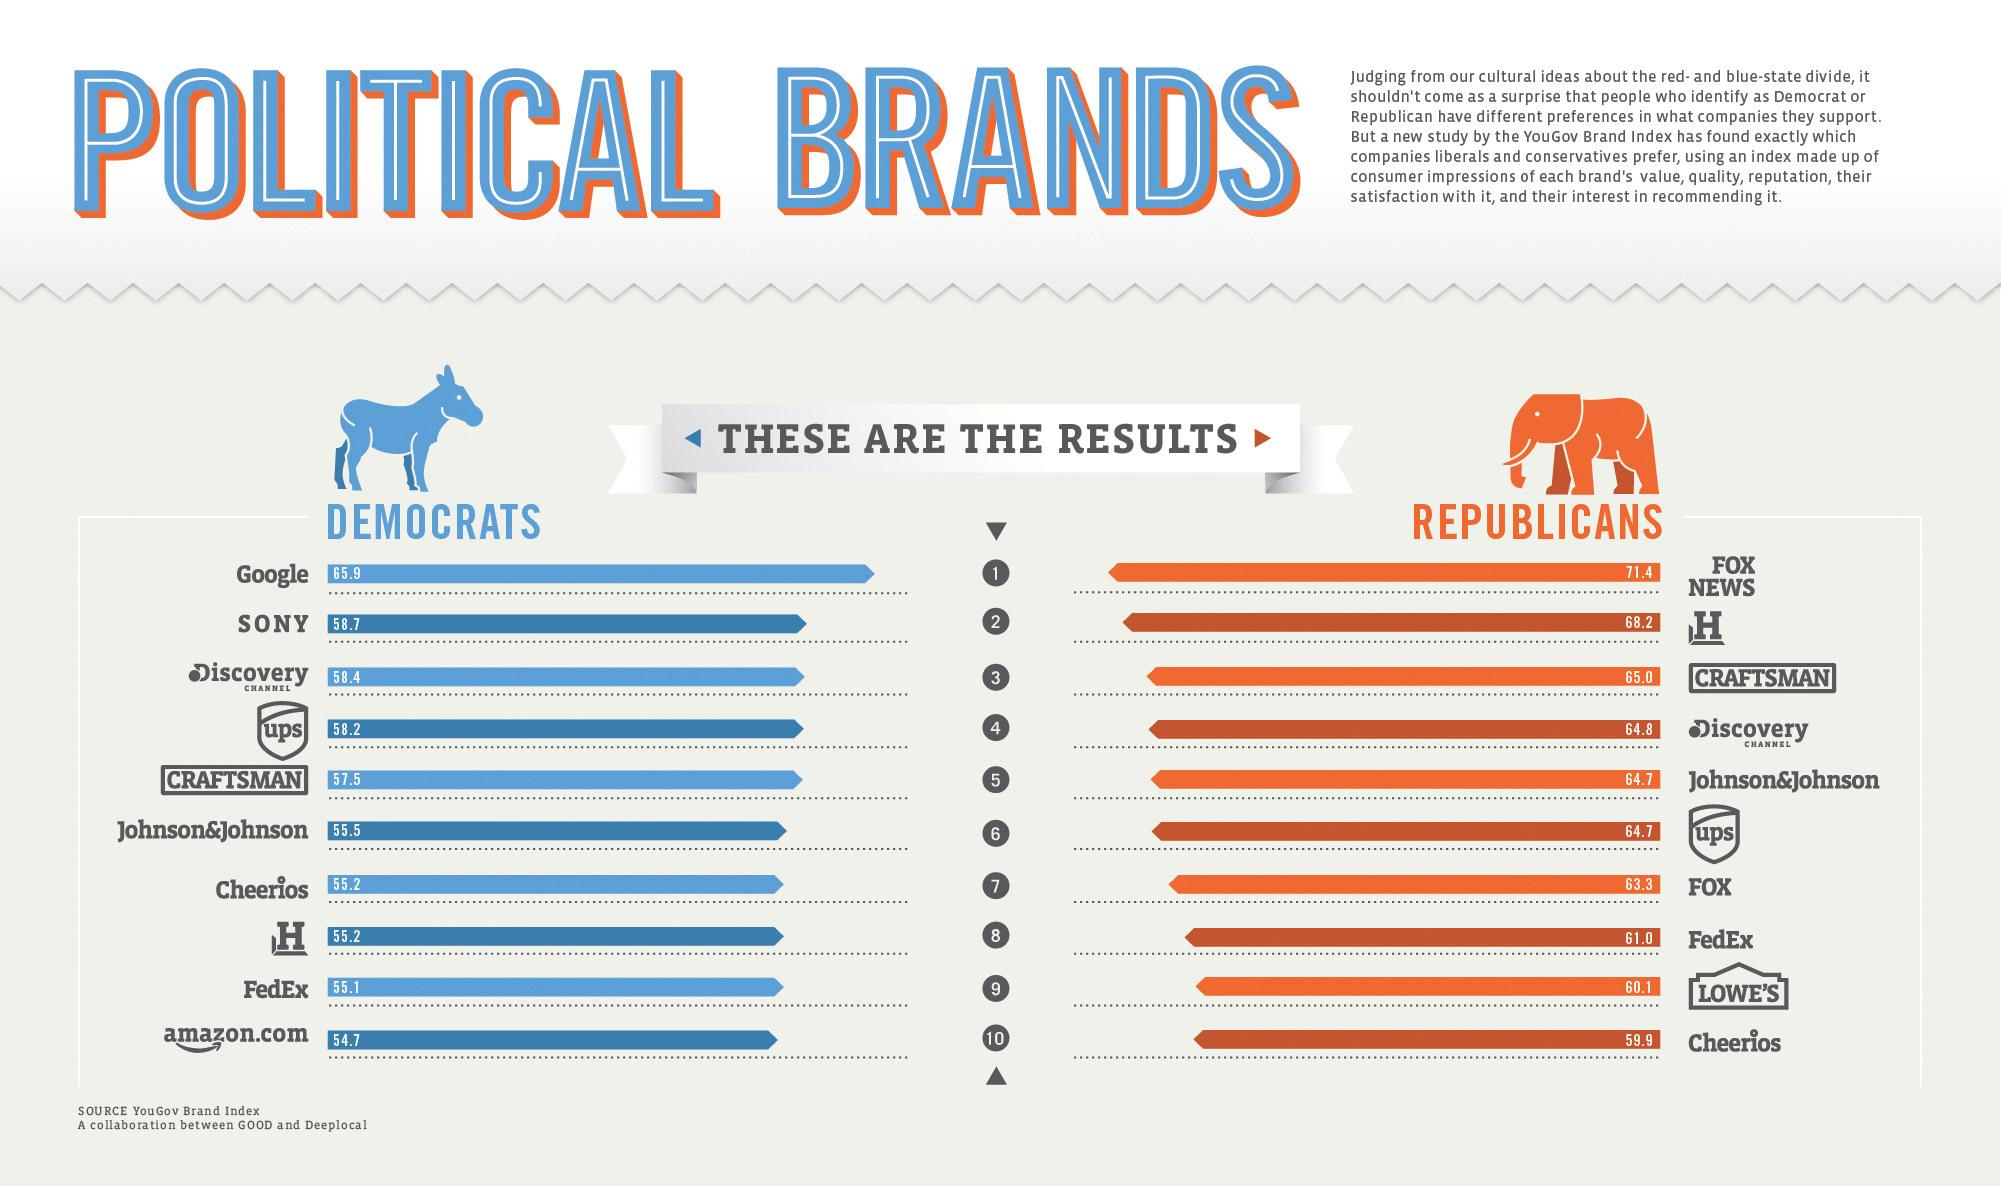Draw attention to some important aspects in this diagram. According to the given data, a large percentage of Republicans in the United States have a positive perception of Johnson & Johnson, UPS, and other brands, with 64.7% of Republicans expressing favorable sentiments towards Johnson & Johnson and 56.8% expressing favorable sentiments towards UPS. The cereal brand that is more popular among Democrats than Republicans is Cheerios. FOX NEWS is the only news channel that is primarily used by Republicans. According to a recent survey, 55.1% of Democrats use Fedex. A popular brand is used by a higher percentage of Democrats (58.2%) than Republicans (64.7%). 